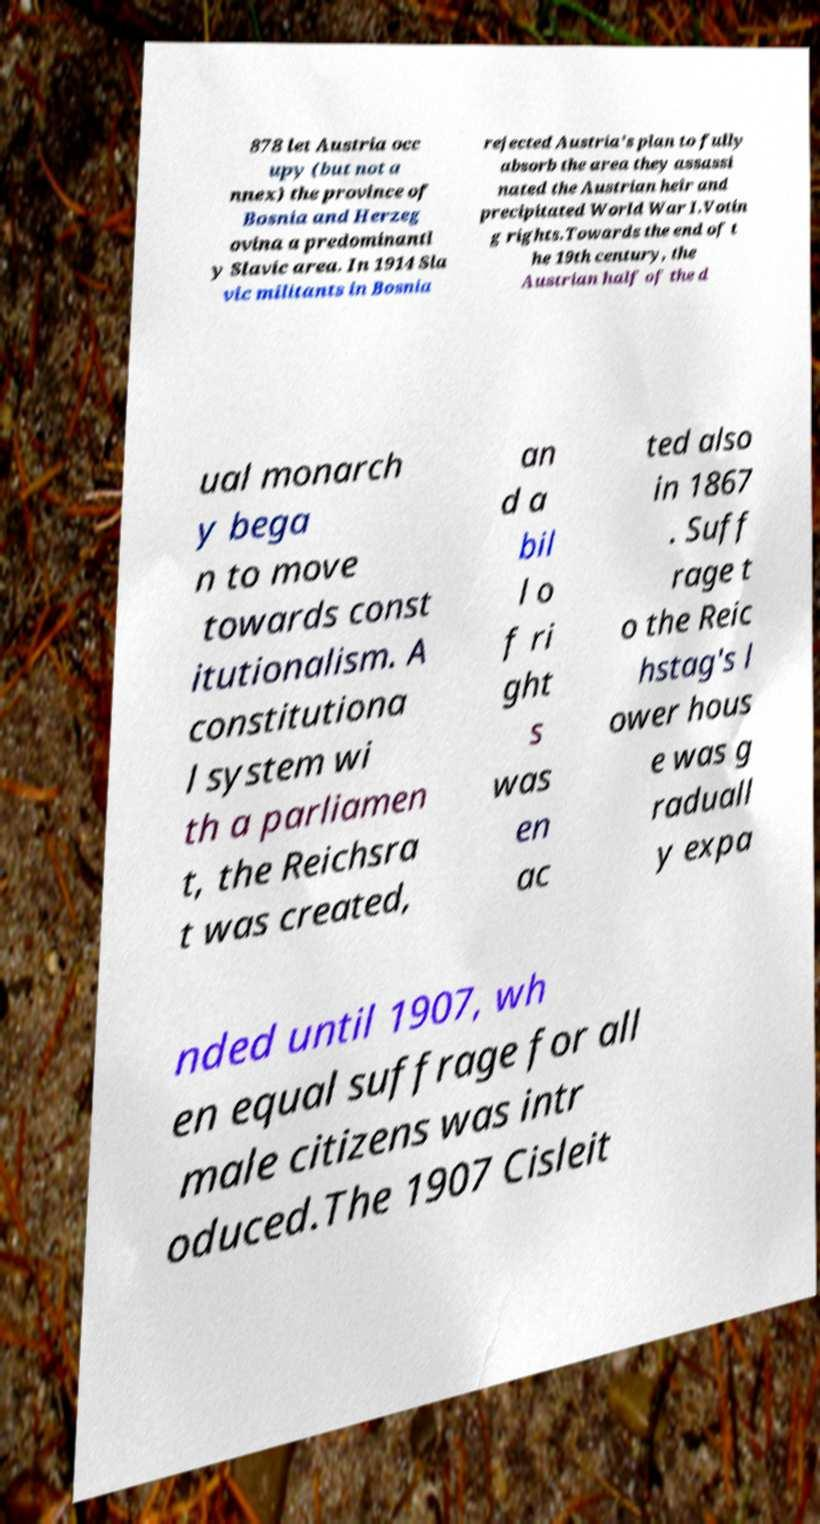I need the written content from this picture converted into text. Can you do that? 878 let Austria occ upy (but not a nnex) the province of Bosnia and Herzeg ovina a predominantl y Slavic area. In 1914 Sla vic militants in Bosnia rejected Austria's plan to fully absorb the area they assassi nated the Austrian heir and precipitated World War I.Votin g rights.Towards the end of t he 19th century, the Austrian half of the d ual monarch y bega n to move towards const itutionalism. A constitutiona l system wi th a parliamen t, the Reichsra t was created, an d a bil l o f ri ght s was en ac ted also in 1867 . Suff rage t o the Reic hstag's l ower hous e was g raduall y expa nded until 1907, wh en equal suffrage for all male citizens was intr oduced.The 1907 Cisleit 